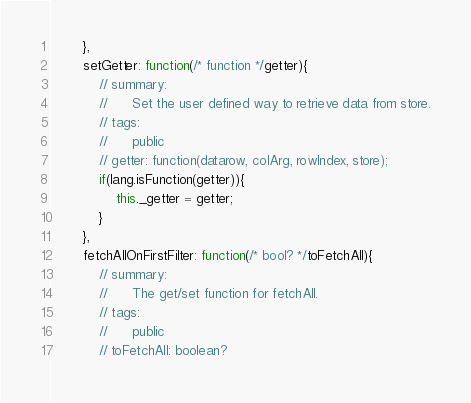Convert code to text. <code><loc_0><loc_0><loc_500><loc_500><_JavaScript_>		},
		setGetter: function(/* function */getter){
			// summary:
			//		Set the user defined way to retrieve data from store.
			// tags:
			//		public
			// getter: function(datarow, colArg, rowIndex, store);
			if(lang.isFunction(getter)){
				this._getter = getter;
			}
		},
		fetchAllOnFirstFilter: function(/* bool? */toFetchAll){
			// summary:
			//		The get/set function for fetchAll.
			// tags:
			//		public
			// toFetchAll: boolean?</code> 